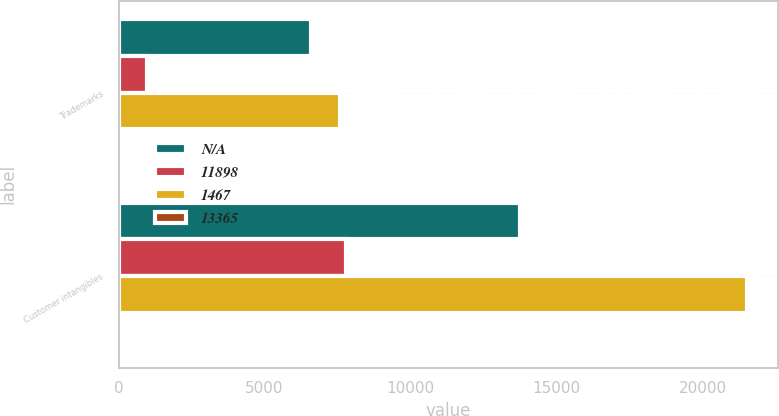<chart> <loc_0><loc_0><loc_500><loc_500><stacked_bar_chart><ecel><fcel>Trademarks<fcel>Customer intangibles<nl><fcel>nan<fcel>6590<fcel>13730<nl><fcel>11898<fcel>991<fcel>7783<nl><fcel>1467<fcel>7581<fcel>21513<nl><fcel>13365<fcel>15<fcel>9<nl></chart> 